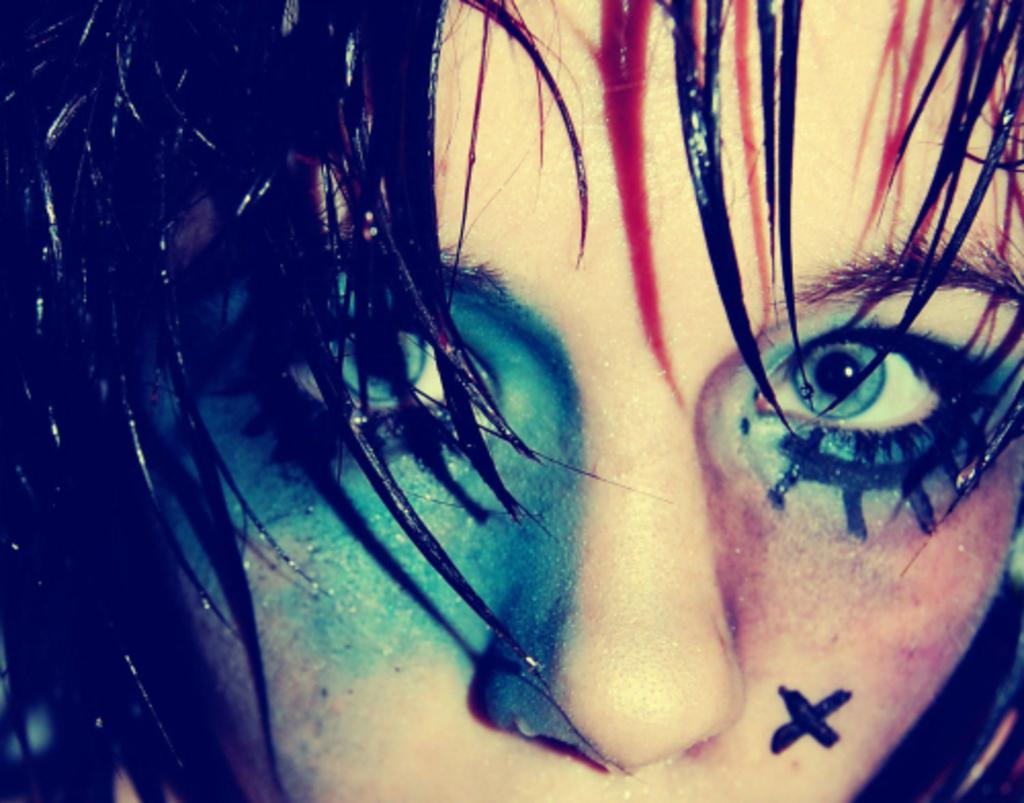What is the main subject of the picture? The main subject of the picture is an image of a woman. Can you describe any specific features or characteristics of the woman? The woman has color marks on her face. What time of day is the giraffe visible in the image? There is no giraffe present in the image, so it cannot be determined what time of day it might be visible. 